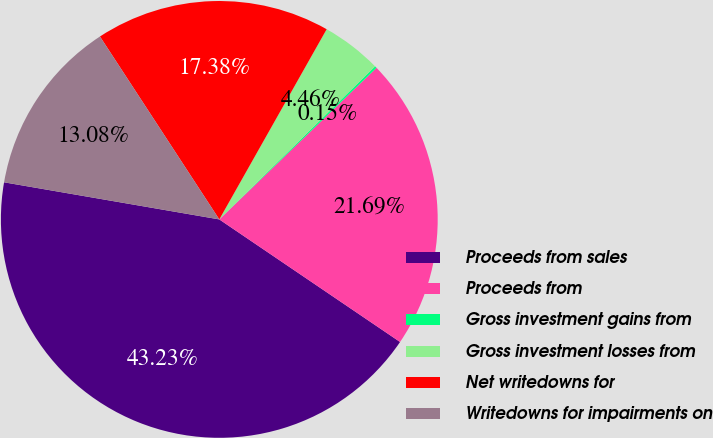Convert chart to OTSL. <chart><loc_0><loc_0><loc_500><loc_500><pie_chart><fcel>Proceeds from sales<fcel>Proceeds from<fcel>Gross investment gains from<fcel>Gross investment losses from<fcel>Net writedowns for<fcel>Writedowns for impairments on<nl><fcel>43.23%<fcel>21.69%<fcel>0.15%<fcel>4.46%<fcel>17.38%<fcel>13.08%<nl></chart> 